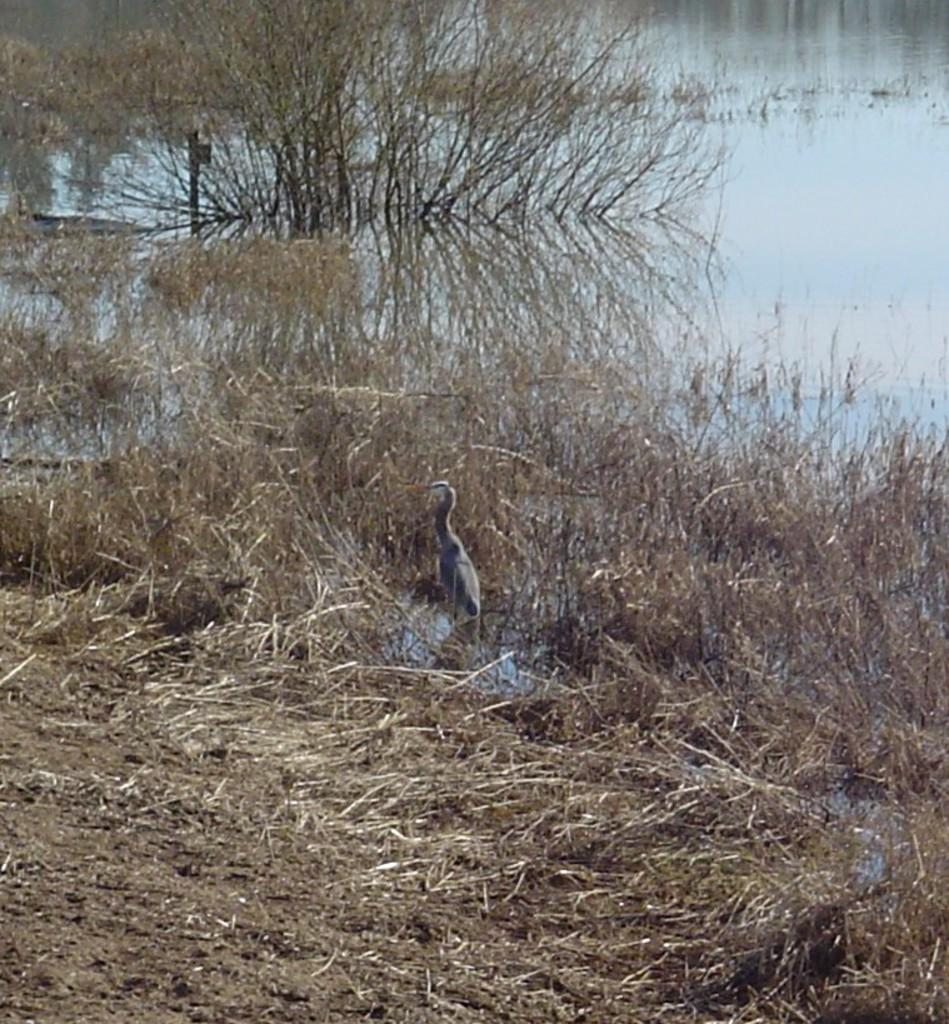What type of animal is present in the image? There is a swan in the image. What type of vegetation can be seen in the image? Plants, grass, and trees are visible in the image. What is the body of water like in the image? There is water in the image. What is the pole used for in the image? The purpose of the pole is not specified in the image. What is the ground made of in the image? The ground is visible at the bottom of the image. What type of nose does the swan have in the image? Swans do not have noses; they have beaks. However, the image does not provide any information about the swan's beak. Is the water in the image hot or cold? The temperature of the water is not specified in the image. 